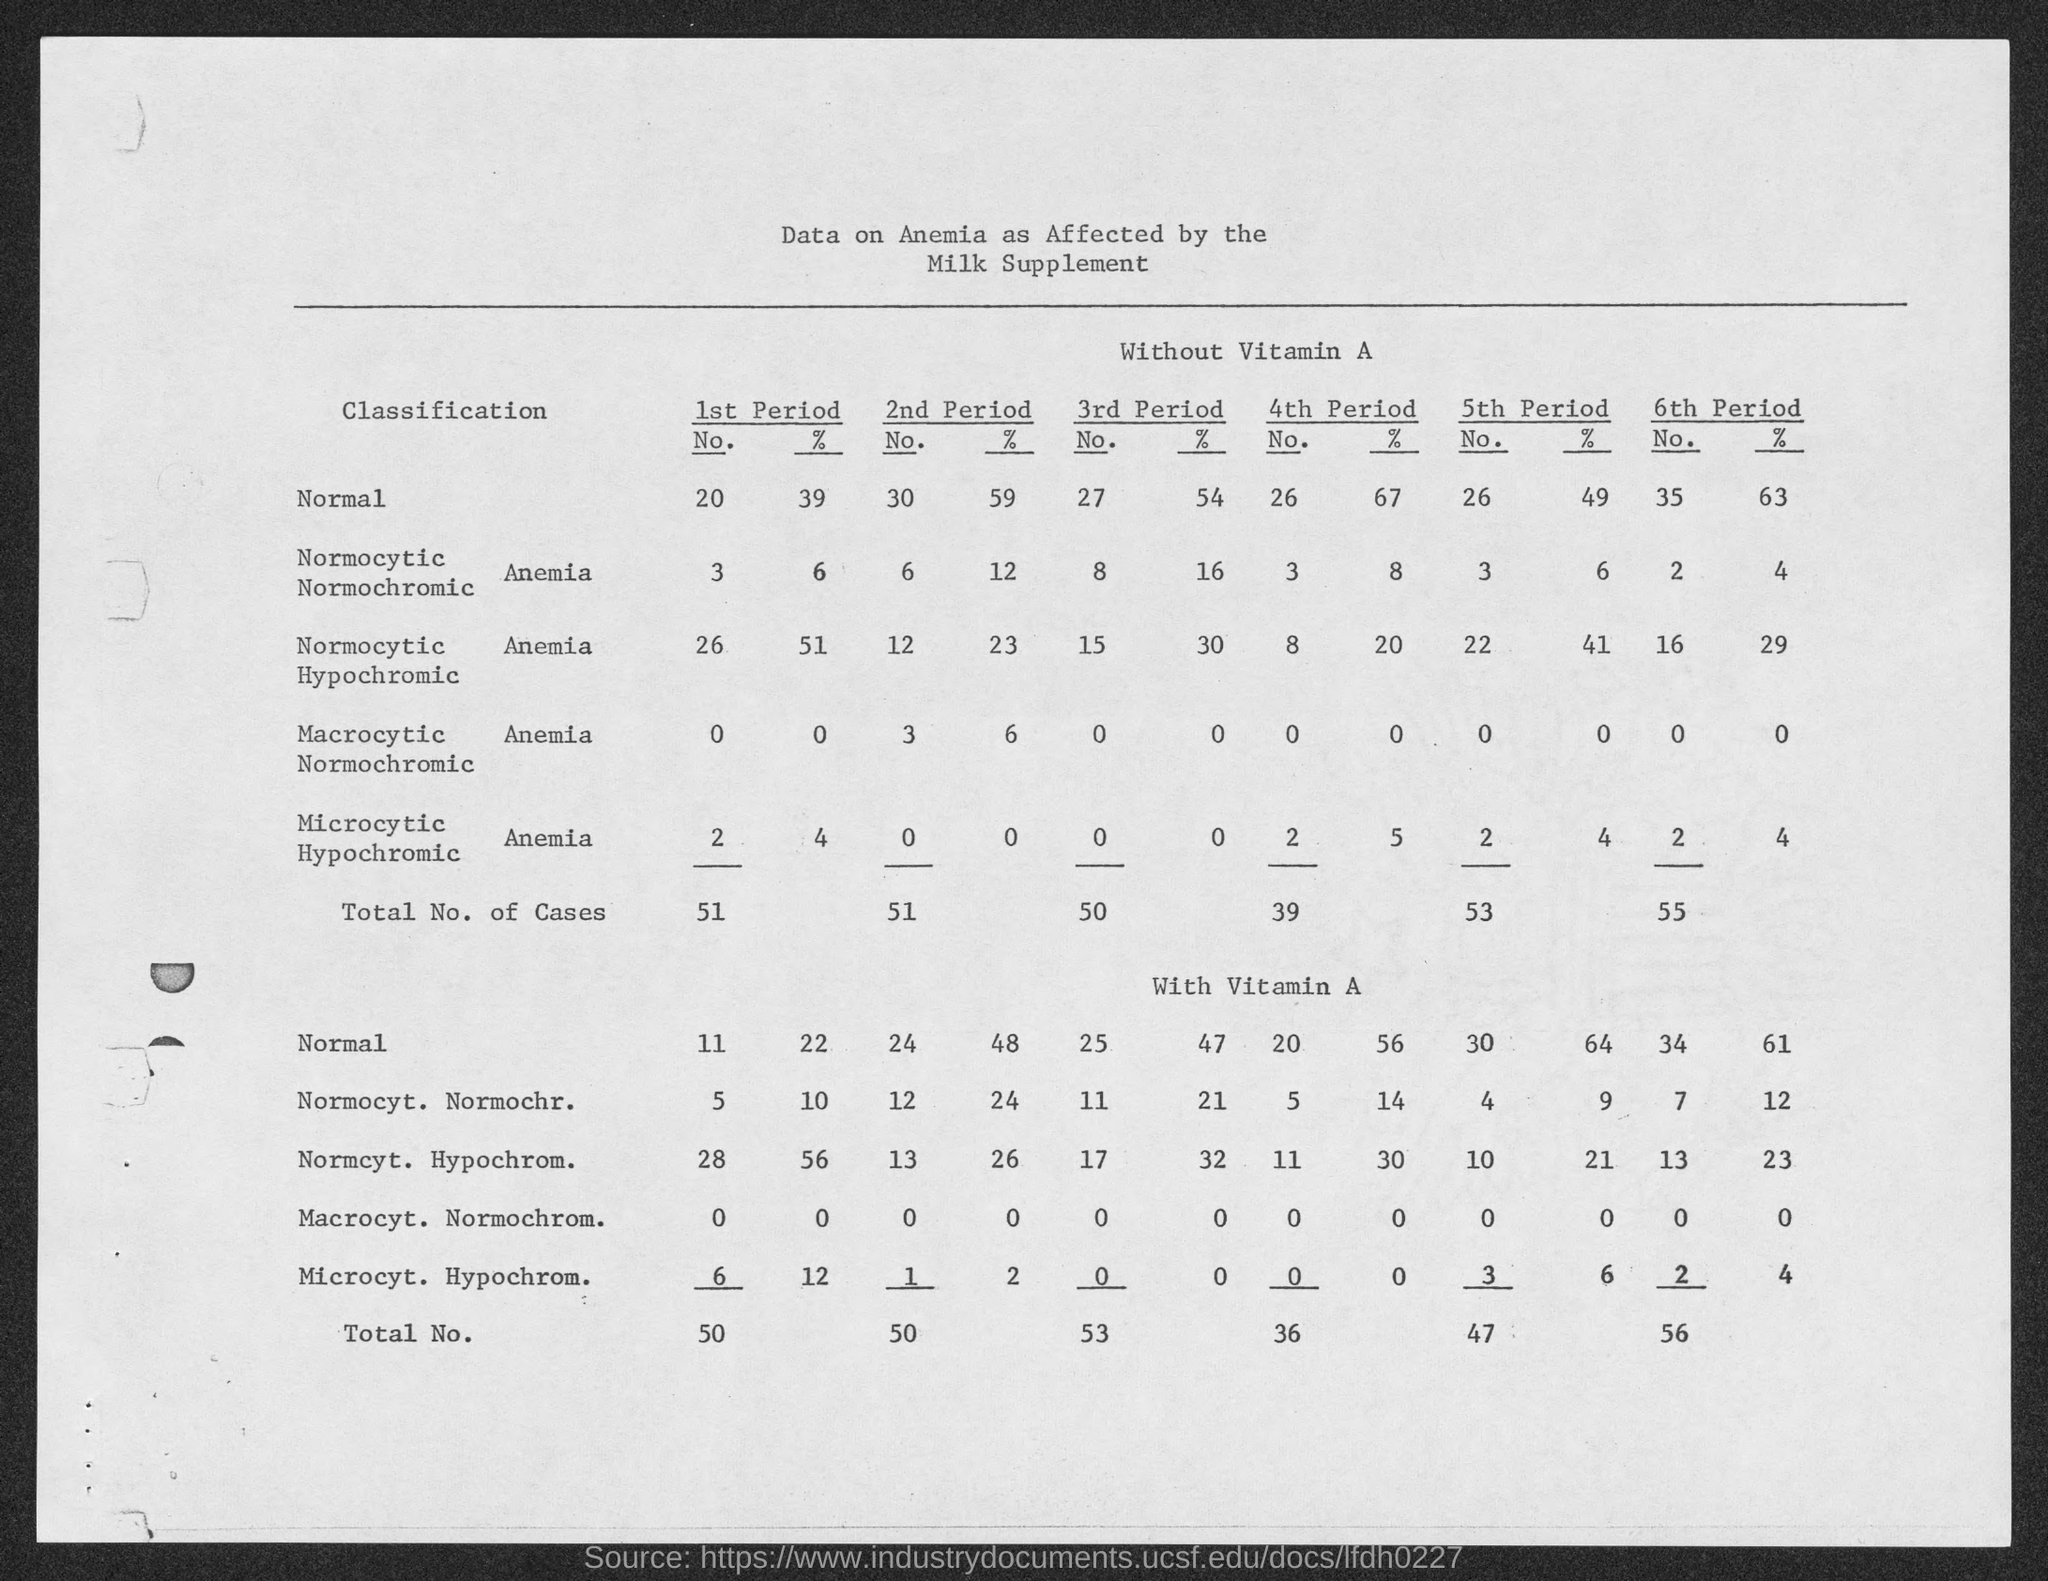What is the title of the table?
Ensure brevity in your answer.  Data on anemia as affected by the milk supplement. 